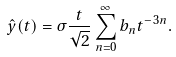Convert formula to latex. <formula><loc_0><loc_0><loc_500><loc_500>\hat { y } ( t ) = \sigma \frac { t } { \sqrt { 2 } } \sum _ { n = 0 } ^ { \infty } b _ { n } t ^ { - 3 n } .</formula> 